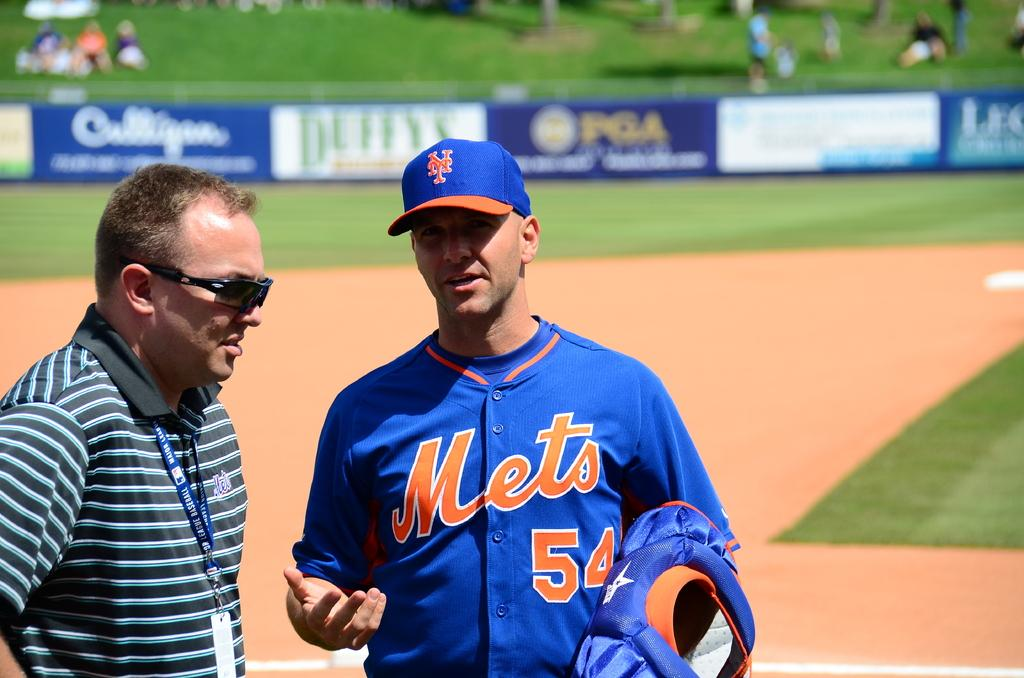<image>
Describe the image concisely. A Mets baseball player who wears number 54 talks to a man wearing sunglasses. 